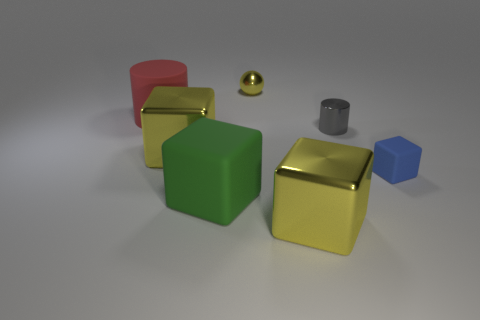Subtract all blue cubes. How many cubes are left? 3 Subtract all purple cylinders. How many yellow cubes are left? 2 Subtract all small blue cubes. How many cubes are left? 3 Add 1 big green rubber cubes. How many objects exist? 8 Subtract all purple blocks. Subtract all cyan cylinders. How many blocks are left? 4 Subtract all blocks. How many objects are left? 3 Add 5 big matte cylinders. How many big matte cylinders are left? 6 Add 3 yellow metallic cylinders. How many yellow metallic cylinders exist? 3 Subtract 1 red cylinders. How many objects are left? 6 Subtract all big gray rubber things. Subtract all blue matte things. How many objects are left? 6 